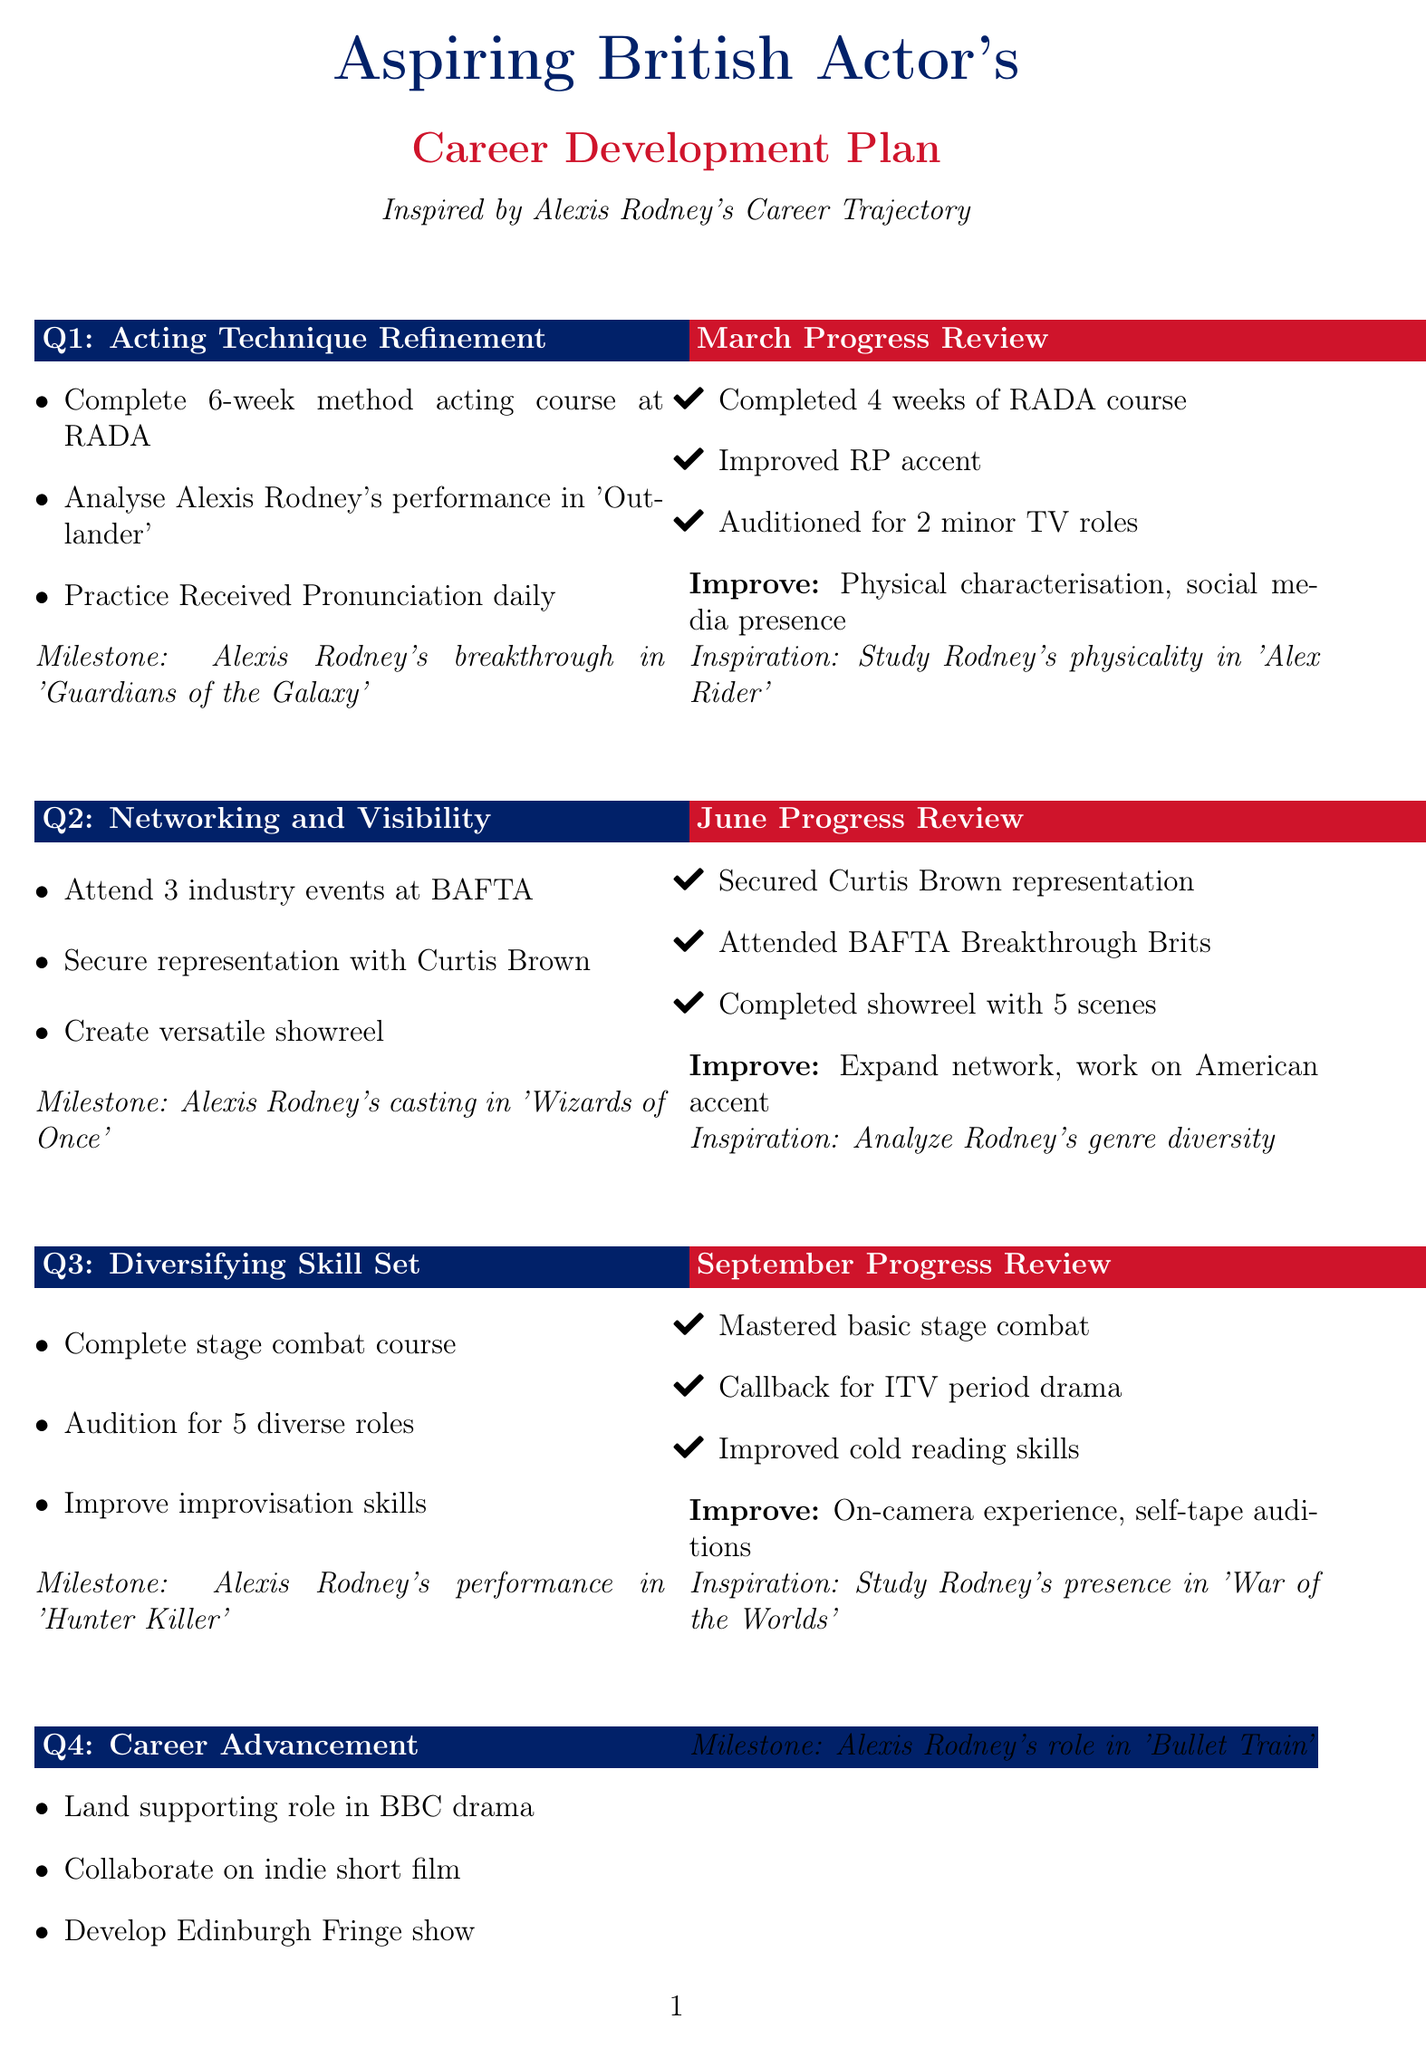What is the focus of Q2? The focus of Q2 is about improving connections and enhancing visibility within the acting industry.
Answer: Networking and Visibility Which course should be completed in Q3? The document outlines that a stage combat course needs to be finished in Q3 for skill diversification.
Answer: stage combat course What was the career milestone in Q1? The milestone in Q1 represents a significant achievement in Alexis Rodney's career.
Answer: Alexis Rodney's breakthrough in 'Guardians of the Galaxy' In which month was the representation by Curtis Brown secured? The representation was secured in June, as part of the progress review for Q2.
Answer: June What was the achievement noted in March progress review? The achievement signifies what was accomplished in March, a key month for setting goals.
Answer: Completed 4 weeks of RADA course What is a focus area for improvement from the September review? Focus areas indicate where more effort is needed to enhance performance after the review is assessed.
Answer: on-camera experience How many industry events should be attended in Q2? This specifies the number of events the actor aimed to attend in Q2 to build their network.
Answer: 3 What is the final goal for Q4? This goal encapsulates the aspirations set for the last quarter of the year, emphasizing career progression.
Answer: Develop a one-person show for the Edinburgh Fringe Festival Which role did Alexis Rodney land in Q4? The document highlights a specific role achieved by Rodney, marking a significant progression in his career.
Answer: role in 'Bullet Train' 